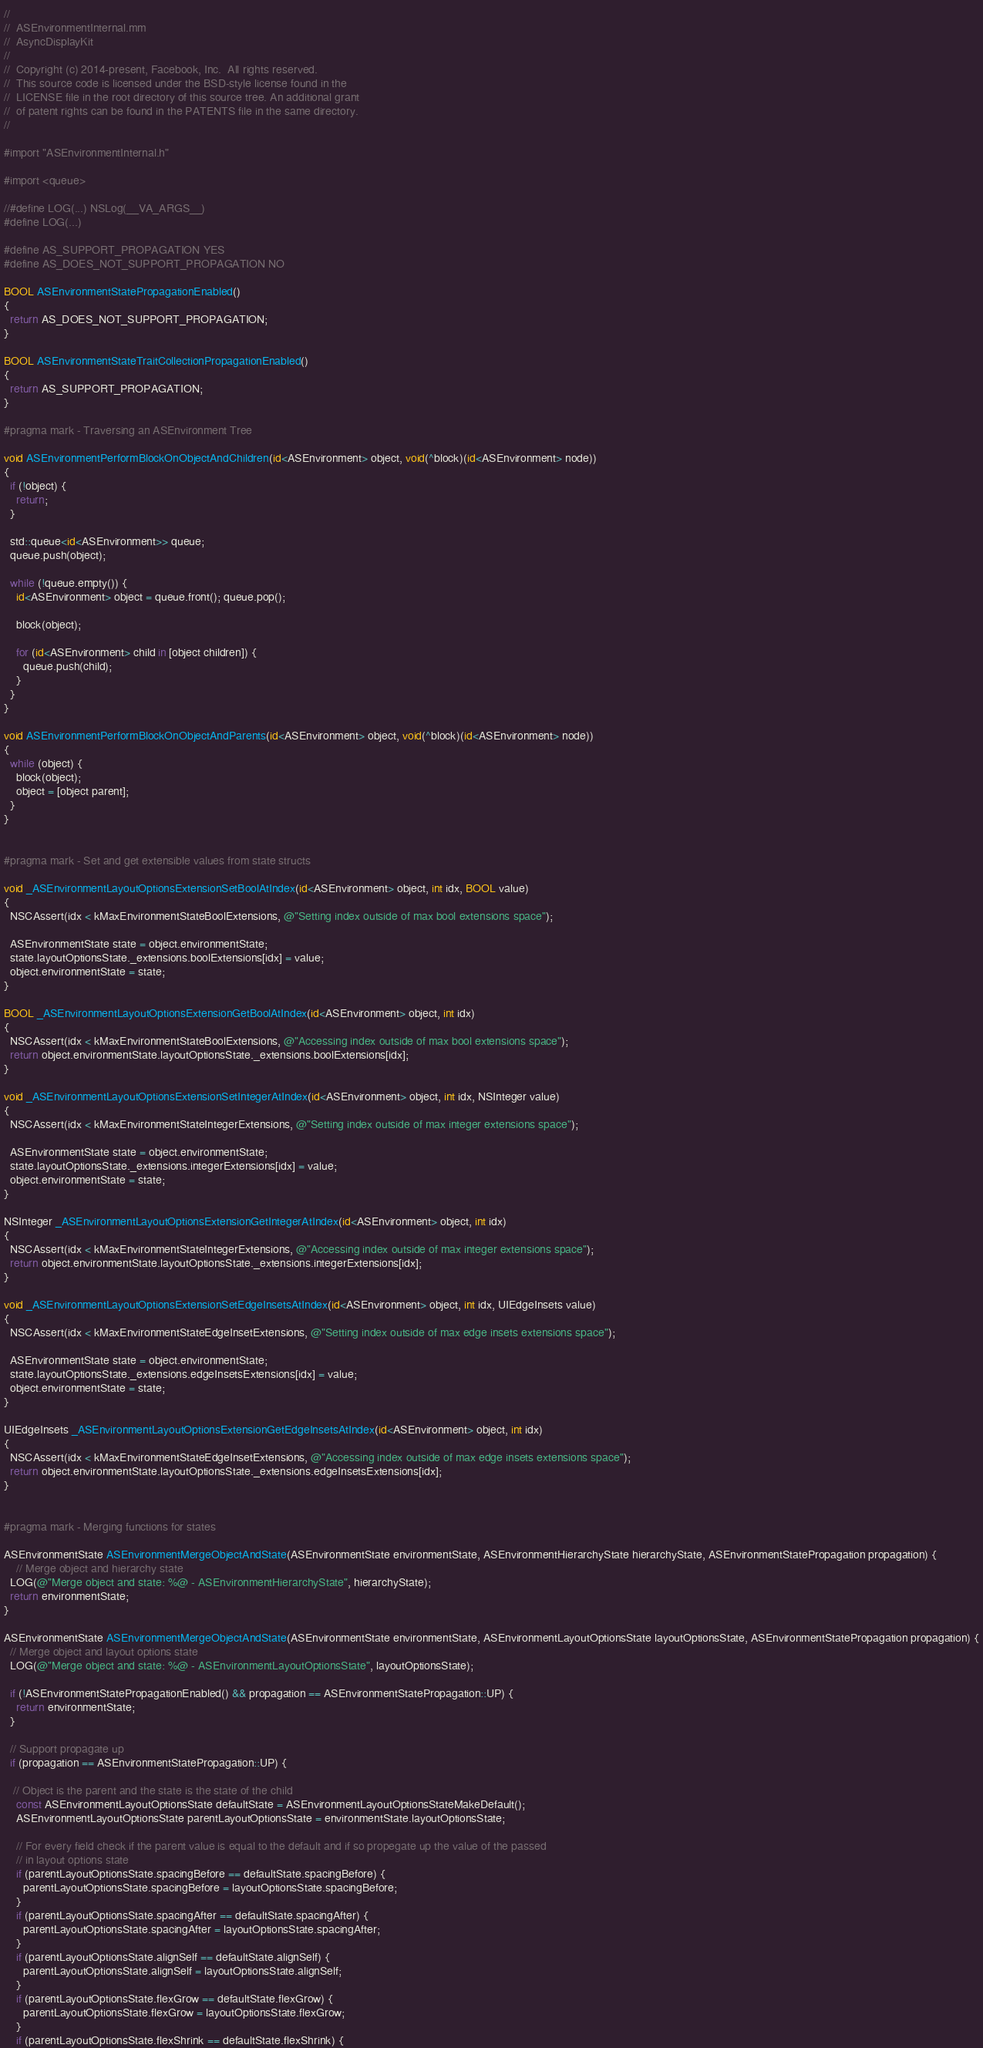Convert code to text. <code><loc_0><loc_0><loc_500><loc_500><_ObjectiveC_>//
//  ASEnvironmentInternal.mm
//  AsyncDisplayKit
//
//  Copyright (c) 2014-present, Facebook, Inc.  All rights reserved.
//  This source code is licensed under the BSD-style license found in the
//  LICENSE file in the root directory of this source tree. An additional grant
//  of patent rights can be found in the PATENTS file in the same directory.
//

#import "ASEnvironmentInternal.h"

#import <queue>

//#define LOG(...) NSLog(__VA_ARGS__)
#define LOG(...)

#define AS_SUPPORT_PROPAGATION YES
#define AS_DOES_NOT_SUPPORT_PROPAGATION NO

BOOL ASEnvironmentStatePropagationEnabled()
{
  return AS_DOES_NOT_SUPPORT_PROPAGATION;
}

BOOL ASEnvironmentStateTraitCollectionPropagationEnabled()
{
  return AS_SUPPORT_PROPAGATION;
}

#pragma mark - Traversing an ASEnvironment Tree

void ASEnvironmentPerformBlockOnObjectAndChildren(id<ASEnvironment> object, void(^block)(id<ASEnvironment> node))
{
  if (!object) {
    return;
  }
  
  std::queue<id<ASEnvironment>> queue;
  queue.push(object);
  
  while (!queue.empty()) {
    id<ASEnvironment> object = queue.front(); queue.pop();
    
    block(object);
    
    for (id<ASEnvironment> child in [object children]) {
      queue.push(child);
    }
  }
}

void ASEnvironmentPerformBlockOnObjectAndParents(id<ASEnvironment> object, void(^block)(id<ASEnvironment> node))
{
  while (object) {
    block(object);
    object = [object parent];
  }
}


#pragma mark - Set and get extensible values from state structs

void _ASEnvironmentLayoutOptionsExtensionSetBoolAtIndex(id<ASEnvironment> object, int idx, BOOL value)
{
  NSCAssert(idx < kMaxEnvironmentStateBoolExtensions, @"Setting index outside of max bool extensions space");
  
  ASEnvironmentState state = object.environmentState;
  state.layoutOptionsState._extensions.boolExtensions[idx] = value;
  object.environmentState = state;
}

BOOL _ASEnvironmentLayoutOptionsExtensionGetBoolAtIndex(id<ASEnvironment> object, int idx)
{
  NSCAssert(idx < kMaxEnvironmentStateBoolExtensions, @"Accessing index outside of max bool extensions space");
  return object.environmentState.layoutOptionsState._extensions.boolExtensions[idx];
}

void _ASEnvironmentLayoutOptionsExtensionSetIntegerAtIndex(id<ASEnvironment> object, int idx, NSInteger value)
{
  NSCAssert(idx < kMaxEnvironmentStateIntegerExtensions, @"Setting index outside of max integer extensions space");
  
  ASEnvironmentState state = object.environmentState;
  state.layoutOptionsState._extensions.integerExtensions[idx] = value;
  object.environmentState = state;
}

NSInteger _ASEnvironmentLayoutOptionsExtensionGetIntegerAtIndex(id<ASEnvironment> object, int idx)
{
  NSCAssert(idx < kMaxEnvironmentStateIntegerExtensions, @"Accessing index outside of max integer extensions space");
  return object.environmentState.layoutOptionsState._extensions.integerExtensions[idx];
}

void _ASEnvironmentLayoutOptionsExtensionSetEdgeInsetsAtIndex(id<ASEnvironment> object, int idx, UIEdgeInsets value)
{
  NSCAssert(idx < kMaxEnvironmentStateEdgeInsetExtensions, @"Setting index outside of max edge insets extensions space");
  
  ASEnvironmentState state = object.environmentState;
  state.layoutOptionsState._extensions.edgeInsetsExtensions[idx] = value;
  object.environmentState = state;
}

UIEdgeInsets _ASEnvironmentLayoutOptionsExtensionGetEdgeInsetsAtIndex(id<ASEnvironment> object, int idx)
{
  NSCAssert(idx < kMaxEnvironmentStateEdgeInsetExtensions, @"Accessing index outside of max edge insets extensions space");
  return object.environmentState.layoutOptionsState._extensions.edgeInsetsExtensions[idx];
}


#pragma mark - Merging functions for states

ASEnvironmentState ASEnvironmentMergeObjectAndState(ASEnvironmentState environmentState, ASEnvironmentHierarchyState hierarchyState, ASEnvironmentStatePropagation propagation) {
    // Merge object and hierarchy state
  LOG(@"Merge object and state: %@ - ASEnvironmentHierarchyState", hierarchyState);
  return environmentState;
}

ASEnvironmentState ASEnvironmentMergeObjectAndState(ASEnvironmentState environmentState, ASEnvironmentLayoutOptionsState layoutOptionsState, ASEnvironmentStatePropagation propagation) {
  // Merge object and layout options state
  LOG(@"Merge object and state: %@ - ASEnvironmentLayoutOptionsState", layoutOptionsState);
  
  if (!ASEnvironmentStatePropagationEnabled() && propagation == ASEnvironmentStatePropagation::UP) {
    return environmentState;
  }
  
  // Support propagate up
  if (propagation == ASEnvironmentStatePropagation::UP) {

   // Object is the parent and the state is the state of the child
    const ASEnvironmentLayoutOptionsState defaultState = ASEnvironmentLayoutOptionsStateMakeDefault();
    ASEnvironmentLayoutOptionsState parentLayoutOptionsState = environmentState.layoutOptionsState;
    
    // For every field check if the parent value is equal to the default and if so propegate up the value of the passed
    // in layout options state
    if (parentLayoutOptionsState.spacingBefore == defaultState.spacingBefore) {
      parentLayoutOptionsState.spacingBefore = layoutOptionsState.spacingBefore;
    }
    if (parentLayoutOptionsState.spacingAfter == defaultState.spacingAfter) {
      parentLayoutOptionsState.spacingAfter = layoutOptionsState.spacingAfter;
    }
    if (parentLayoutOptionsState.alignSelf == defaultState.alignSelf) {
      parentLayoutOptionsState.alignSelf = layoutOptionsState.alignSelf;
    }
    if (parentLayoutOptionsState.flexGrow == defaultState.flexGrow) {
      parentLayoutOptionsState.flexGrow = layoutOptionsState.flexGrow;
    }
    if (parentLayoutOptionsState.flexShrink == defaultState.flexShrink) {</code> 